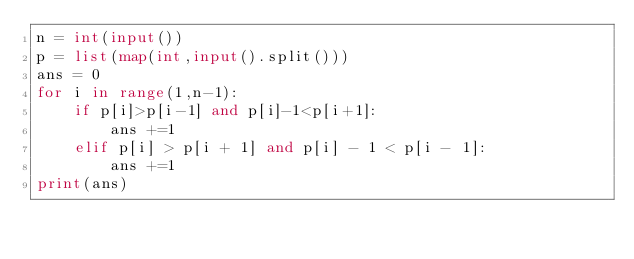Convert code to text. <code><loc_0><loc_0><loc_500><loc_500><_Python_>n = int(input())
p = list(map(int,input().split()))
ans = 0
for i in range(1,n-1):
    if p[i]>p[i-1] and p[i]-1<p[i+1]:
        ans +=1
    elif p[i] > p[i + 1] and p[i] - 1 < p[i - 1]:
        ans +=1
print(ans)</code> 